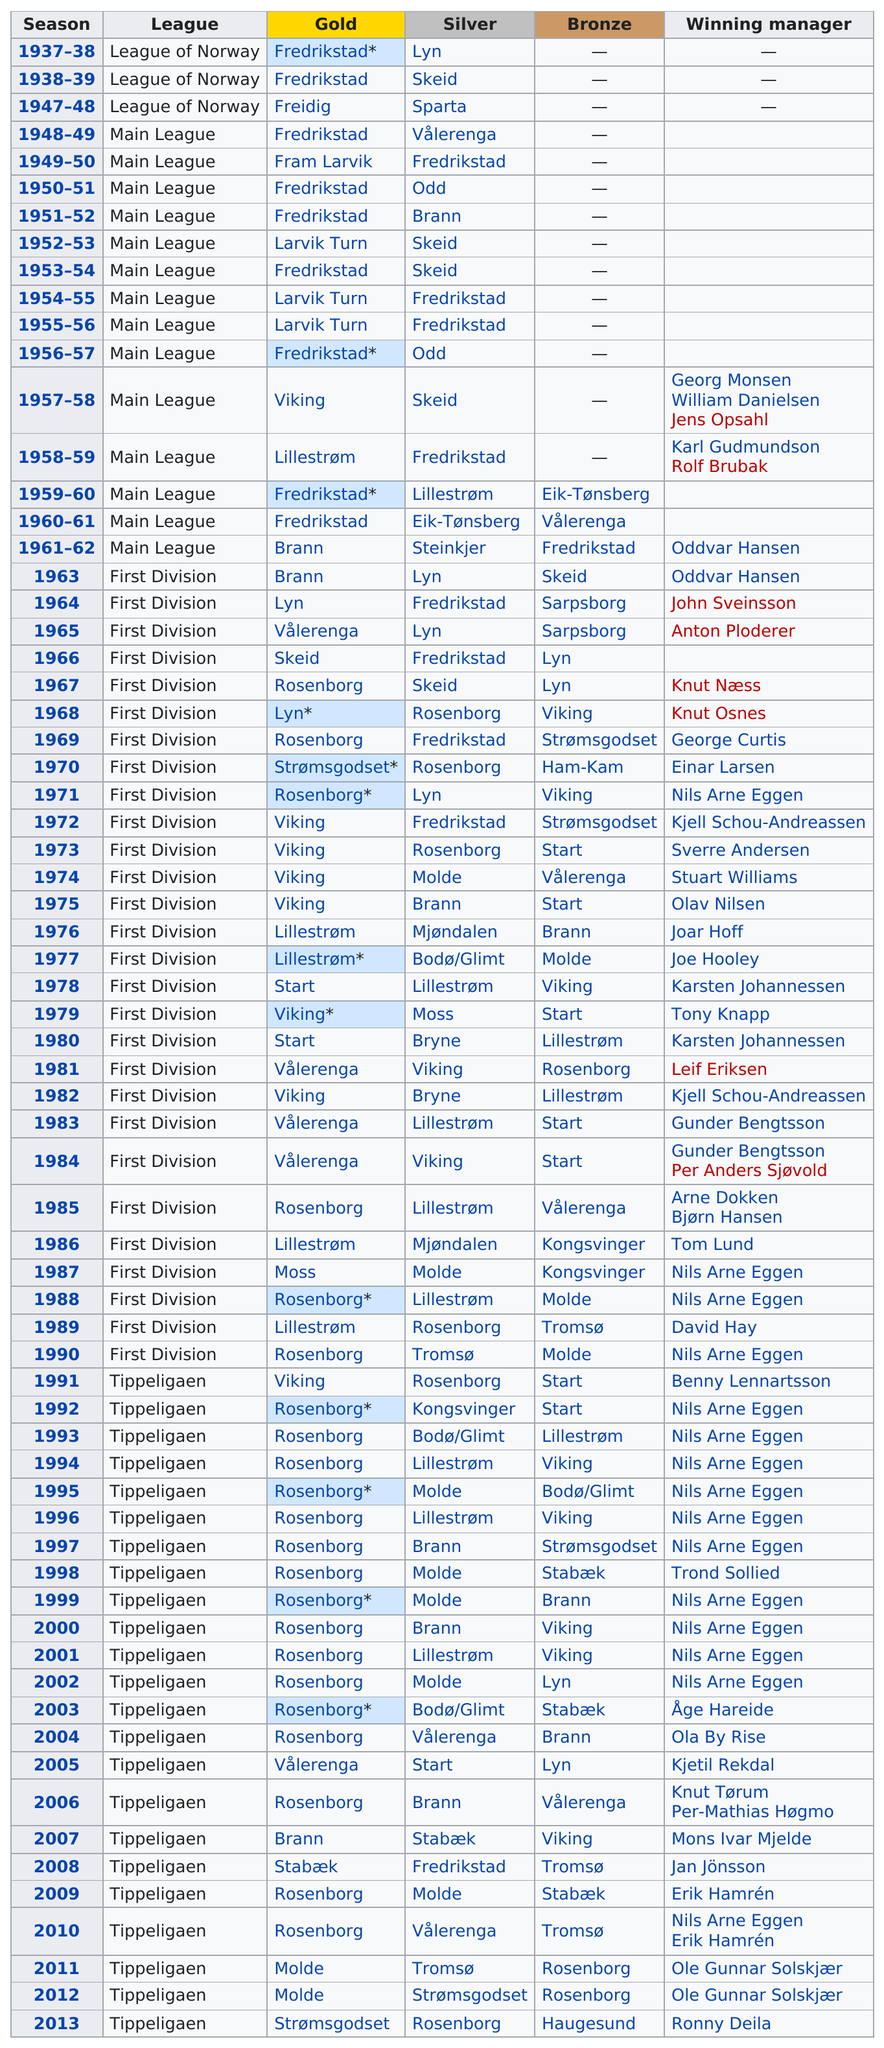Outline some significant characteristics in this image. Prior to the Tippeligaen, the league was known as the First Division. The total number of medals earned by Fredrikstad is 19. Eik-Tønsberg won the bronze medal before Valeranga did in the 1960-61 season. Rosenborg has won a total of 22 titles. Lillestrøm won gold a total of five times. 